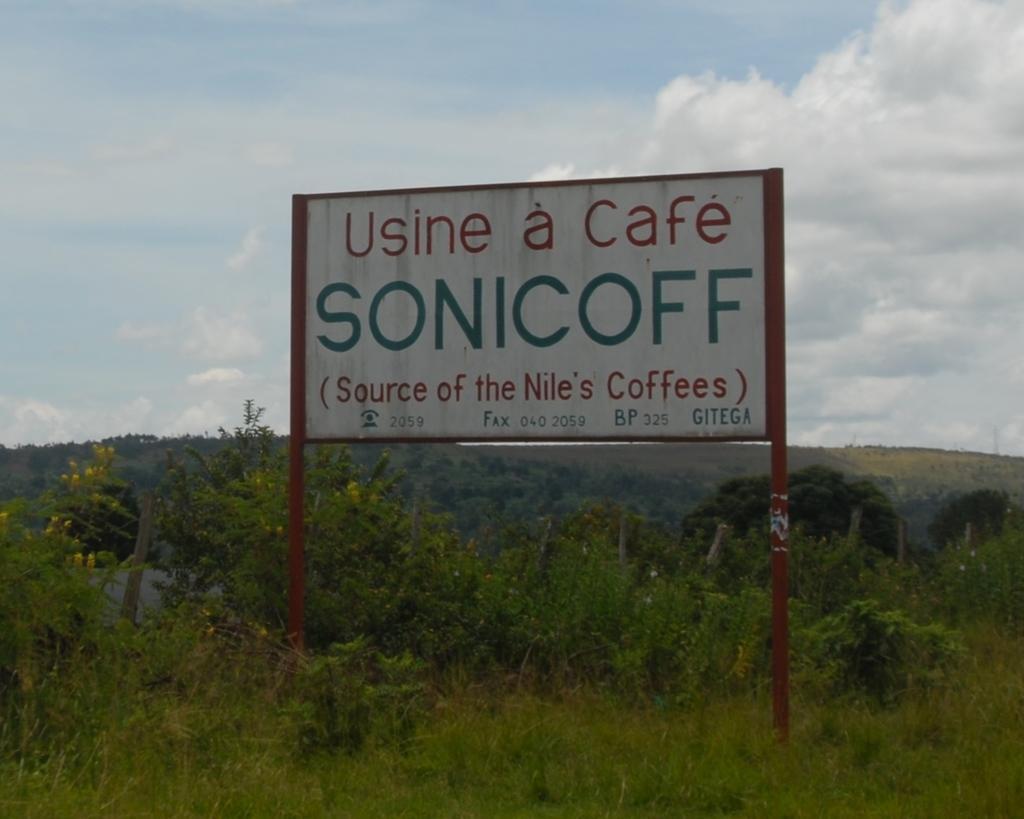How would you summarize this image in a sentence or two? In this image, we can see name board with poles. At the bottom, we can see grass. Background there are few plants, trees, poles, hill and cloudy sky. On the board, we can see some text. 